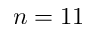Convert formula to latex. <formula><loc_0><loc_0><loc_500><loc_500>n = 1 1</formula> 